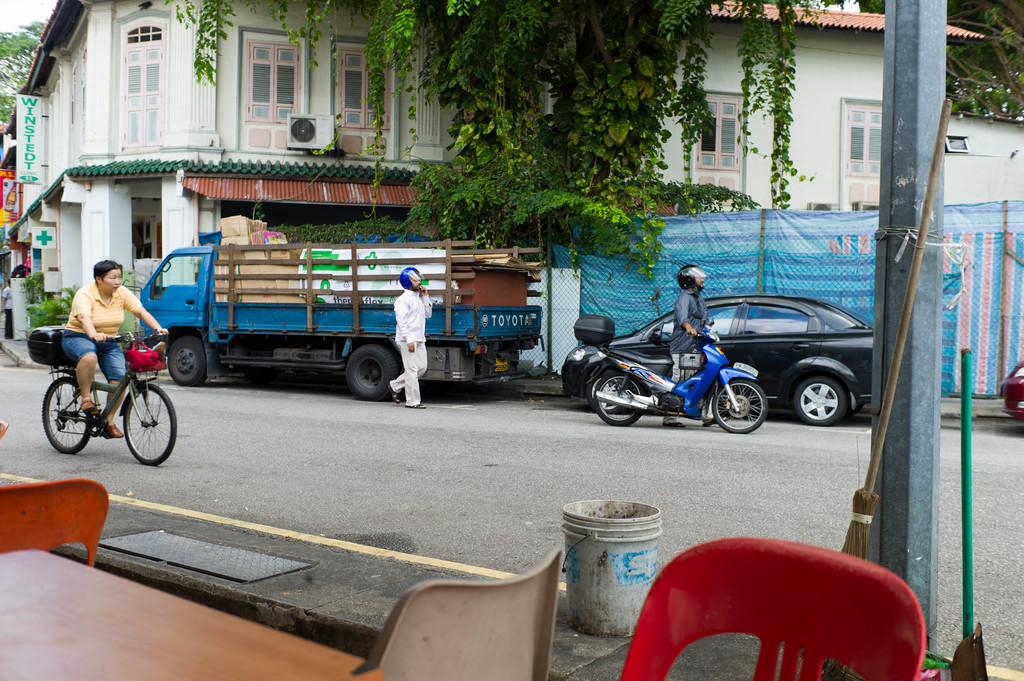How many people are present in the image? There are people in the image, but the exact number is not specified. What are the people doing in the image? One person is with a motorcycle, and another person is cycling a bicycle. What can be seen in the background of the image? There are vehicles, trees, and buildings in the background of the image. Can you hear anyone coughing or crying in the image? There is no auditory information provided in the image, so it is not possible to determine if anyone is coughing or crying. 